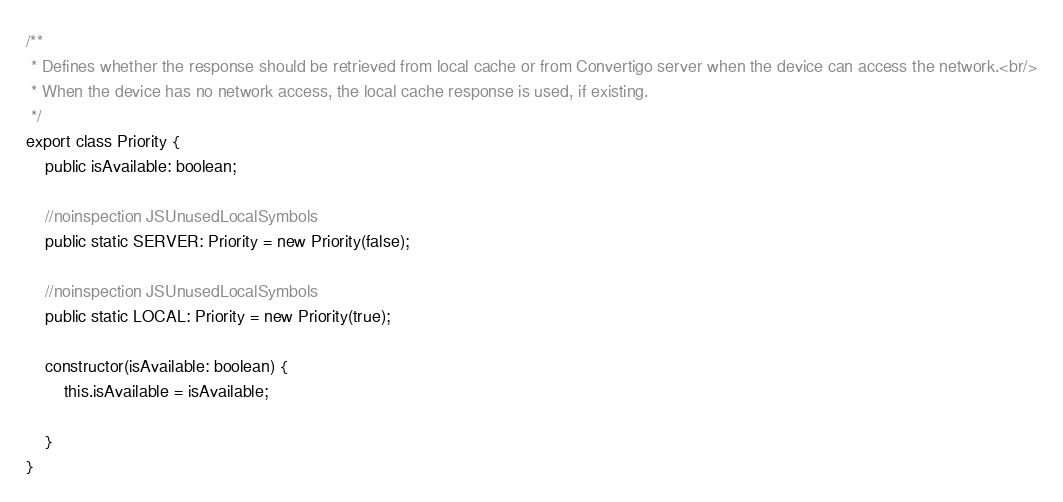<code> <loc_0><loc_0><loc_500><loc_500><_TypeScript_>/**
 * Defines whether the response should be retrieved from local cache or from Convertigo server when the device can access the network.<br/>
 * When the device has no network access, the local cache response is used, if existing.
 */
export class Priority {
    public isAvailable: boolean;

    //noinspection JSUnusedLocalSymbols
    public static SERVER: Priority = new Priority(false);

    //noinspection JSUnusedLocalSymbols
    public static LOCAL: Priority = new Priority(true);

    constructor(isAvailable: boolean) {
        this.isAvailable = isAvailable;

    }
}
</code> 